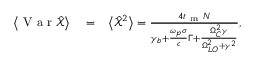Convert formula to latex. <formula><loc_0><loc_0><loc_500><loc_500>\begin{array} { r l r } { \left < V a r \hat { \mathcal { X } } \right > } & = } & { \left < \hat { \mathcal { X } } ^ { 2 } \right > = \frac { 4 t _ { m } N } { { \gamma _ { b } } + \frac { \omega _ { p } \sigma } { c } \Gamma + \frac { \Omega _ { C } ^ { 2 } \gamma } { \Omega _ { L O } ^ { 2 } + \gamma ^ { 2 } } } , } \end{array}</formula> 